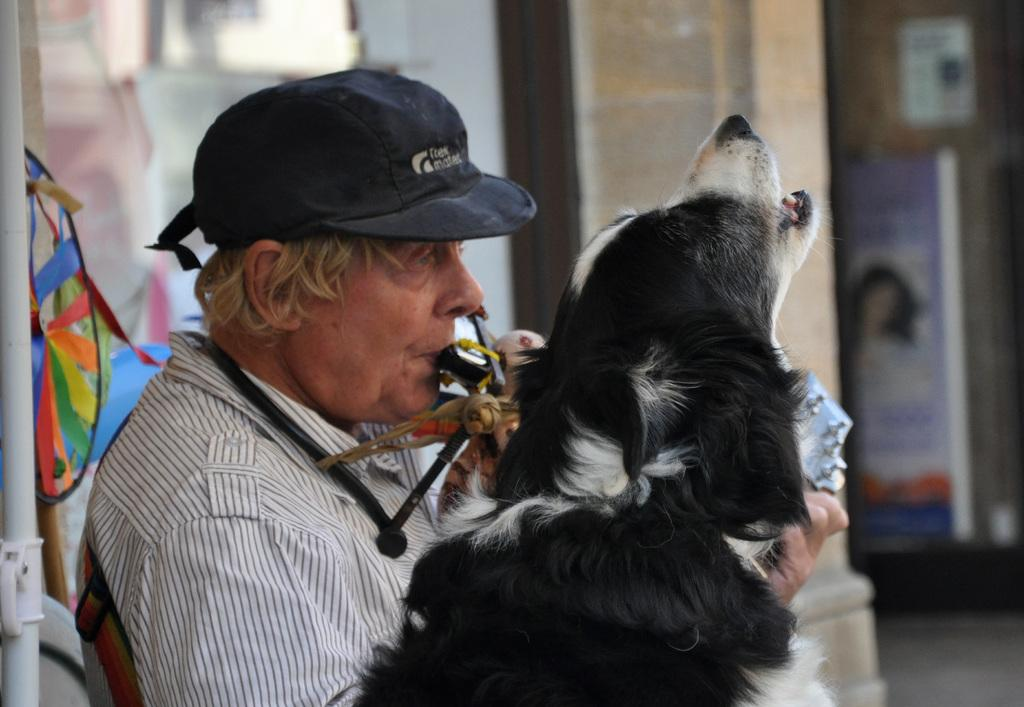Who is present in the image? There is a man in the image. What other living creature is in the image? There is a dog in the image. What is the man doing with his mouth? The man is holding something in his mouth. What is the man wearing on his head? The man is wearing a cap. What can be seen in the background of the image? There is a pillar in the background of the image. What type of toys can be seen on the island in the image? There is no island present in the image, and therefore no toys can be seen on it. 